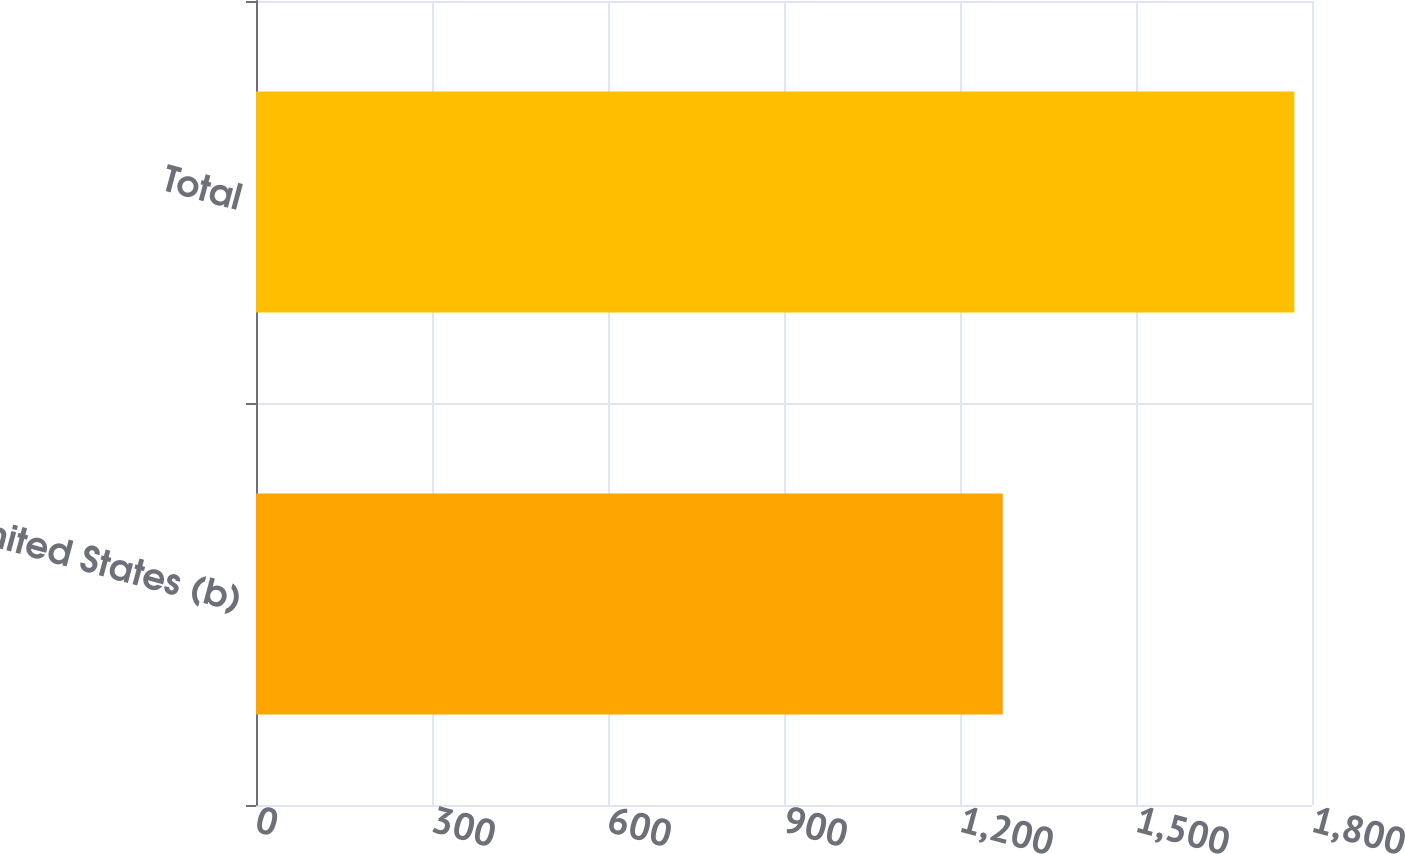Convert chart to OTSL. <chart><loc_0><loc_0><loc_500><loc_500><bar_chart><fcel>United States (b)<fcel>Total<nl><fcel>1273<fcel>1770<nl></chart> 